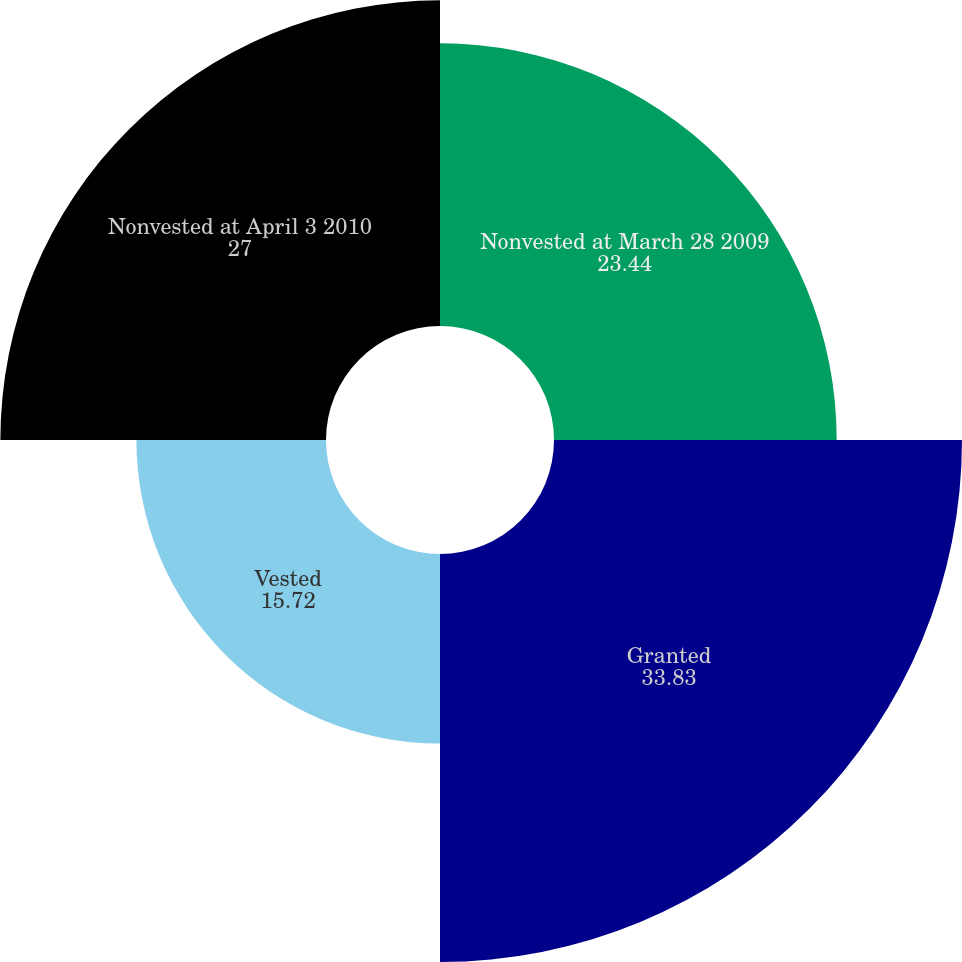Convert chart. <chart><loc_0><loc_0><loc_500><loc_500><pie_chart><fcel>Nonvested at March 28 2009<fcel>Granted<fcel>Vested<fcel>Nonvested at April 3 2010<nl><fcel>23.44%<fcel>33.83%<fcel>15.72%<fcel>27.0%<nl></chart> 